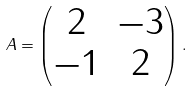Convert formula to latex. <formula><loc_0><loc_0><loc_500><loc_500>A = \begin{pmatrix} 2 & - 3 \\ - 1 & 2 \end{pmatrix} .</formula> 